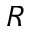<formula> <loc_0><loc_0><loc_500><loc_500>R</formula> 